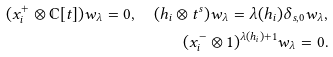<formula> <loc_0><loc_0><loc_500><loc_500>( x ^ { + } _ { i } \otimes \mathbb { C } [ t ] ) w _ { \lambda } = 0 , \ \ ( h _ { i } \otimes t ^ { s } ) w _ { \lambda } = \lambda ( h _ { i } ) \delta _ { s , 0 } w _ { \lambda } , \\ ( x _ { i } ^ { - } \otimes 1 ) ^ { \lambda ( h _ { i } ) + 1 } w _ { \lambda } = 0 .</formula> 